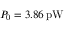Convert formula to latex. <formula><loc_0><loc_0><loc_500><loc_500>P _ { 0 } = 3 . 8 6 \, p W</formula> 